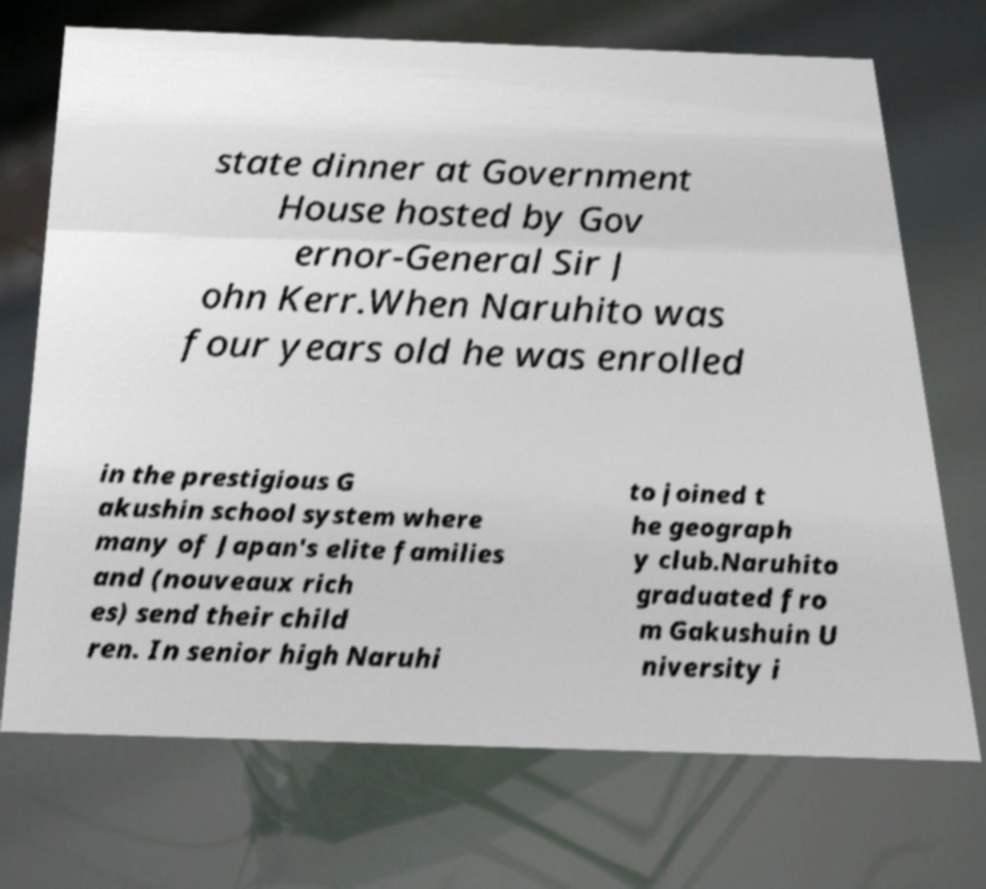Please read and relay the text visible in this image. What does it say? state dinner at Government House hosted by Gov ernor-General Sir J ohn Kerr.When Naruhito was four years old he was enrolled in the prestigious G akushin school system where many of Japan's elite families and (nouveaux rich es) send their child ren. In senior high Naruhi to joined t he geograph y club.Naruhito graduated fro m Gakushuin U niversity i 